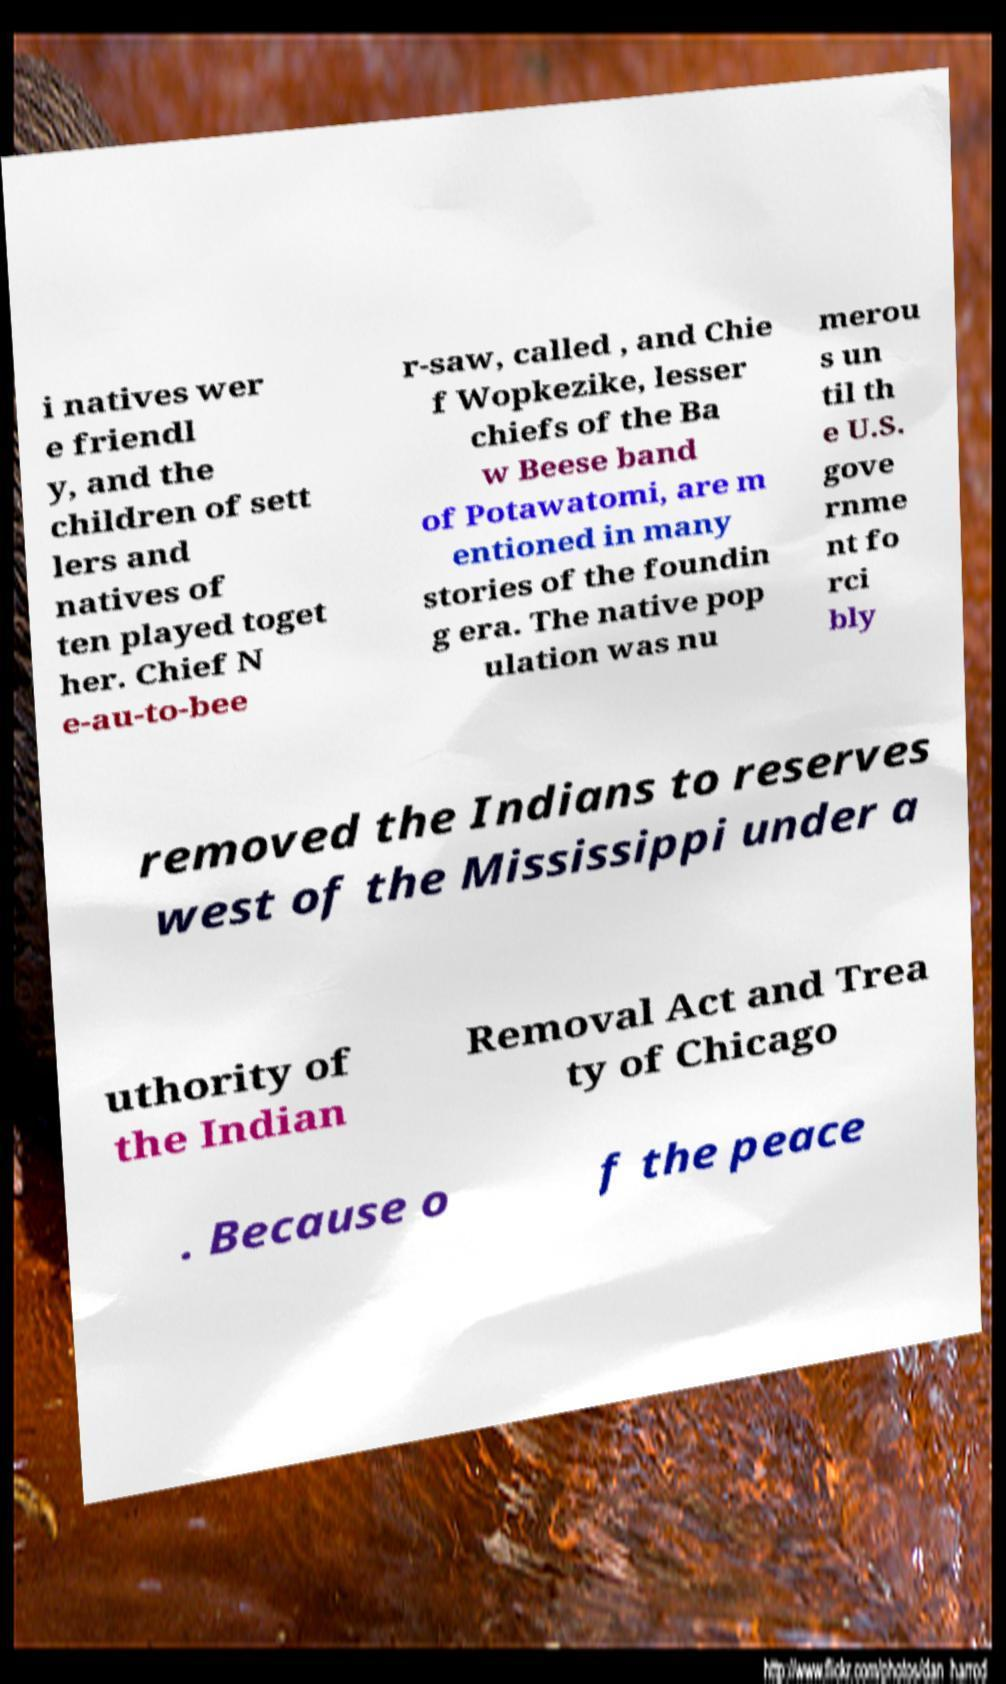What messages or text are displayed in this image? I need them in a readable, typed format. i natives wer e friendl y, and the children of sett lers and natives of ten played toget her. Chief N e-au-to-bee r-saw, called , and Chie f Wopkezike, lesser chiefs of the Ba w Beese band of Potawatomi, are m entioned in many stories of the foundin g era. The native pop ulation was nu merou s un til th e U.S. gove rnme nt fo rci bly removed the Indians to reserves west of the Mississippi under a uthority of the Indian Removal Act and Trea ty of Chicago . Because o f the peace 